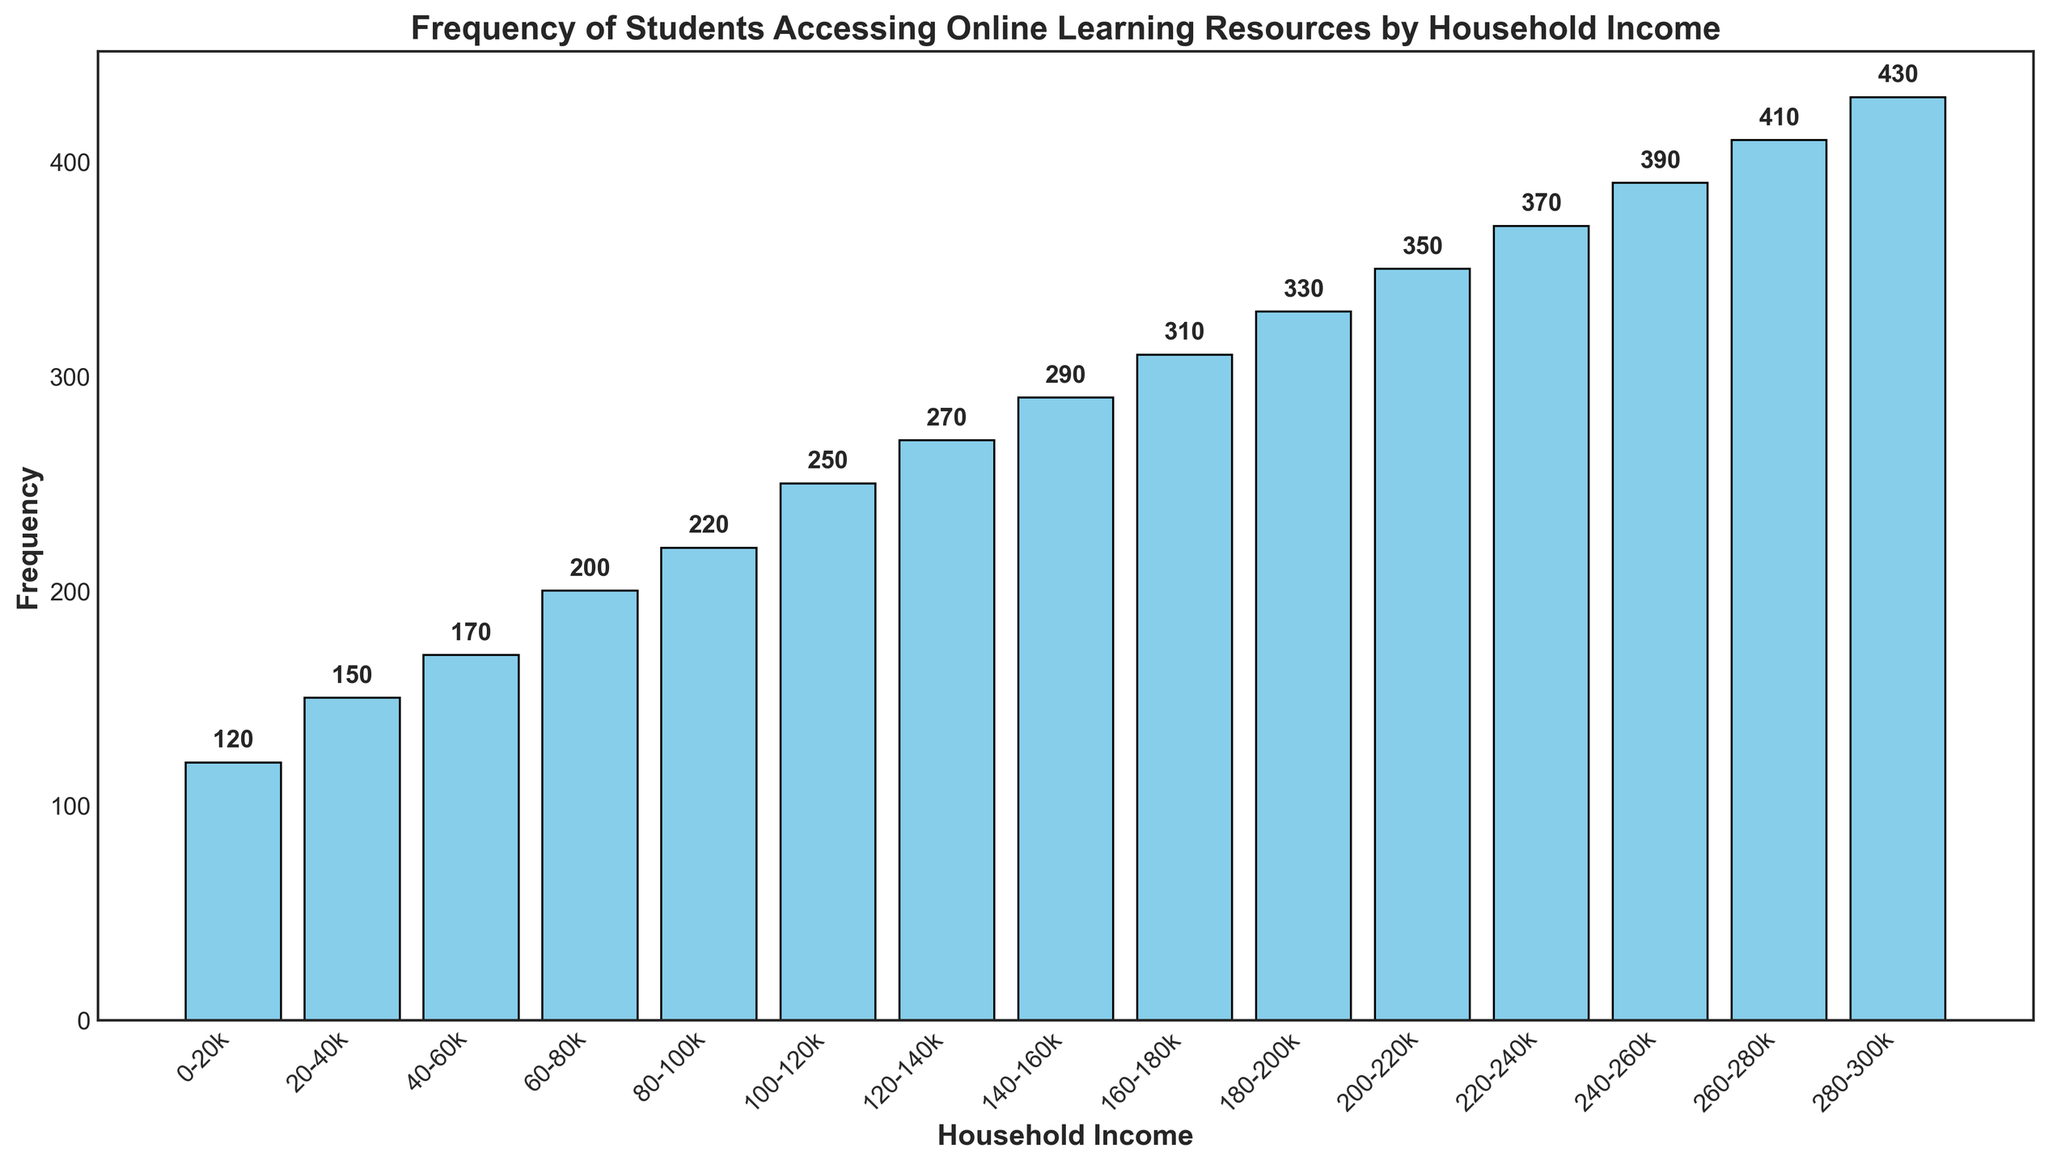What's the highest frequency recorded in any income group? To find the highest frequency, look at the tallest bar in the histogram. The tallest bar reaches up to 430, corresponding to the 280-300k household income group.
Answer: 430 Which household income range has the lowest frequency of students accessing online learning resources? Look for the shortest bar in the histogram. The shortest bar represents the 0-20k household income group with a frequency of 120.
Answer: 0-20k By how much does the frequency increase from the 60-80k income group to the 100-120k income group? Subtract the frequency of the 60-80k group (200) from the frequency of the 100-120k group (250). 250 - 200 = 50.
Answer: 50 What is the total frequency of students accessing online resources in the 20-40k and 40-60k income groups combined? Add the frequency of the 20-40k group (150) to the 40-60k group (170). 150 + 170 = 320.
Answer: 320 Which income groups have a frequency greater than 300? Identify all the bars with heights greater than 300. These are the bars for the income groups 160-180k, 180-200k, 200-220k, 220-240k, 240-260k, 260-280k, and 280-300k.
Answer: 160-180k, 180-200k, 200-220k, 220-240k, 240-260k, 260-280k, 280-300k What is the difference in frequency between the highest and lowest income groups? Subtract the frequency of the lowest income group (120 for 0-20k) from the highest income group (430 for 280-300k). 430 - 120 = 310.
Answer: 310 What is the average frequency of the students from the 100k-200k income range? Add the frequencies for the 100-120k, 120-140k, 140-160k, 160-180k, and 180-200k groups and then divide by 5. (250 + 270 + 290 + 310 + 330) / 5 = 1450 / 5 = 290.
Answer: 290 How many groups have frequencies between 200 and 300? Count the bars with heights between 200 and 300. The groups are: 80-100k (220), 100-120k (250), 120-140k (270), and 140-160k (290). There are 4 groups.
Answer: 4 What is the main color used in the bars of the histogram? Visually identify the color of the bars. All bars are colored skyblue.
Answer: skyblue 